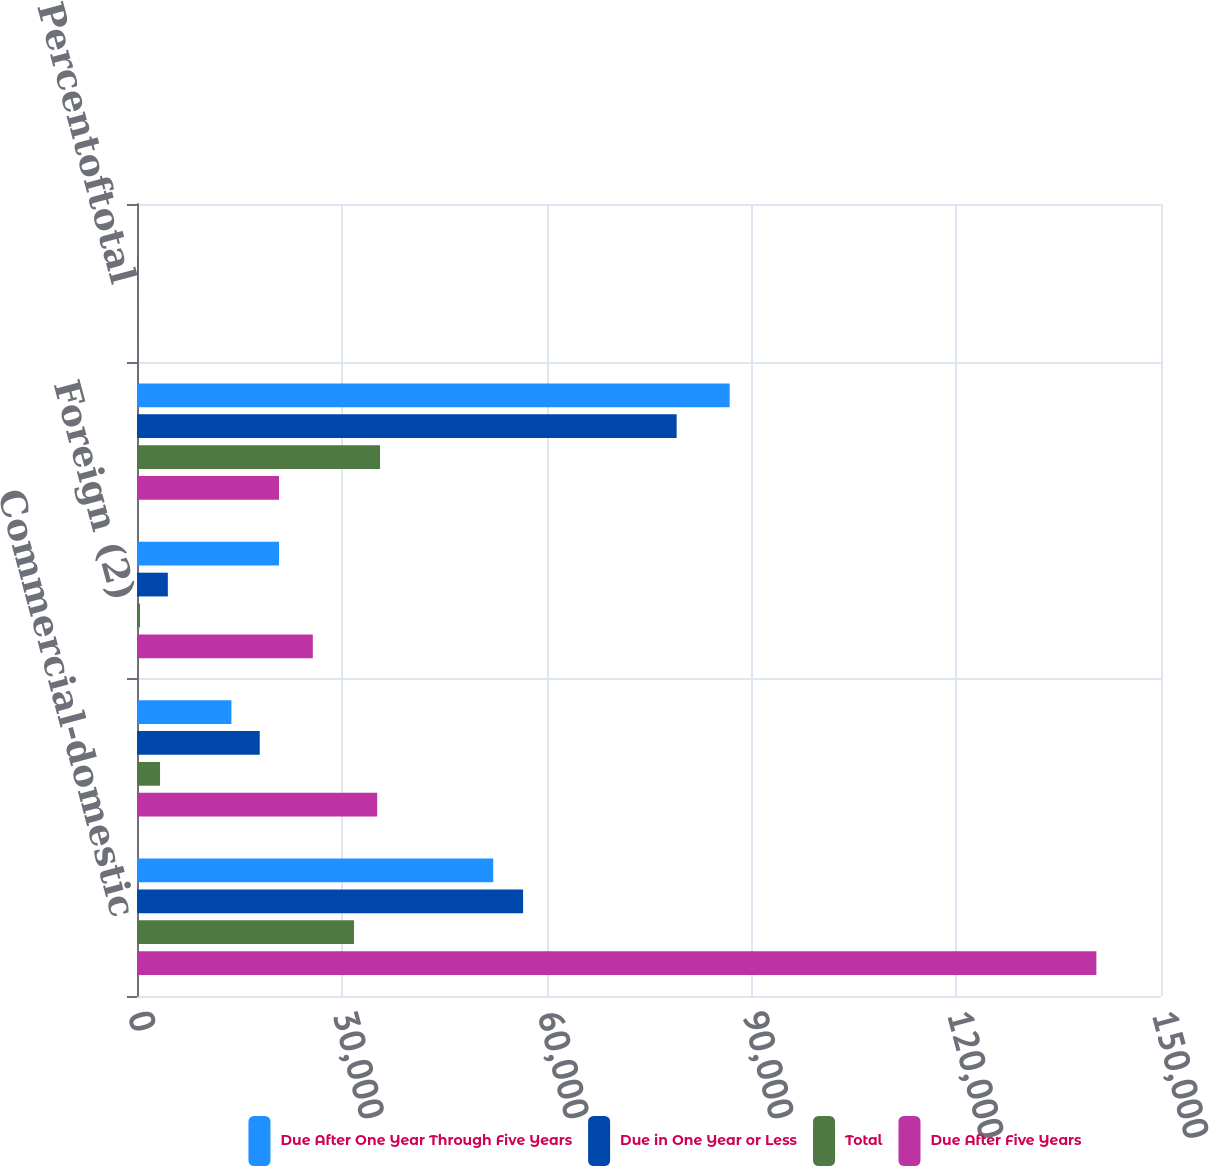Convert chart. <chart><loc_0><loc_0><loc_500><loc_500><stacked_bar_chart><ecel><fcel>Commercial-domestic<fcel>Commercial real<fcel>Foreign (2)<fcel>Total selected loans<fcel>Percentoftotal<nl><fcel>Due After One Year Through Five Years<fcel>52186<fcel>13830<fcel>20801<fcel>86817<fcel>43.1<nl><fcel>Due in One Year or Less<fcel>56557<fcel>17976<fcel>4518<fcel>79051<fcel>39.2<nl><fcel>Total<fcel>31790<fcel>3375<fcel>437<fcel>35602<fcel>17.7<nl><fcel>Due After Five Years<fcel>140533<fcel>35181<fcel>25756<fcel>20801<fcel>100<nl></chart> 